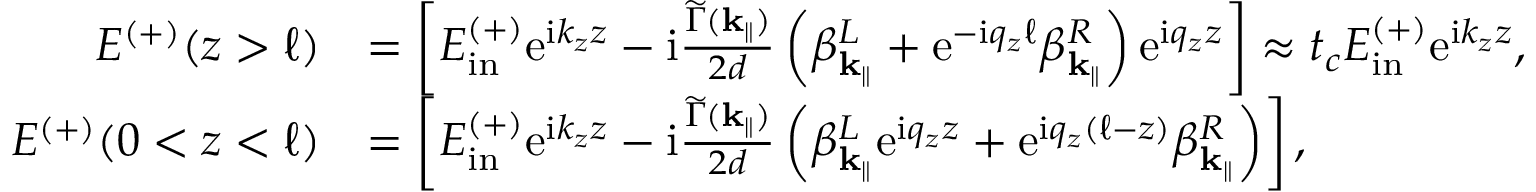Convert formula to latex. <formula><loc_0><loc_0><loc_500><loc_500>\begin{array} { r l } { E ^ { ( + ) } ( z > \ell ) } & { = \left [ E _ { i n } ^ { ( + ) } e ^ { i k _ { z } z } - i \frac { \widetilde { \Gamma } ( k _ { \| } ) } { 2 d } \left ( \beta _ { k _ { \| } } ^ { L } + e ^ { - i q _ { z } \ell } \beta _ { k _ { \| } } ^ { R } \right ) e ^ { i q _ { z } z } \right ] \approx t _ { c } E _ { i n } ^ { ( + ) } e ^ { i k _ { z } z } , } \\ { E ^ { ( + ) } ( 0 < z < \ell ) } & { = \left [ E _ { i n } ^ { ( + ) } e ^ { i k _ { z } z } - i \frac { \widetilde { \Gamma } ( { k _ { \| } } ) } { 2 d } \left ( \beta _ { k _ { \| } } ^ { L } e ^ { i q _ { z } z } + e ^ { i q _ { z } ( \ell - z ) } \beta _ { k _ { \| } } ^ { R } \right ) \right ] , } \end{array}</formula> 